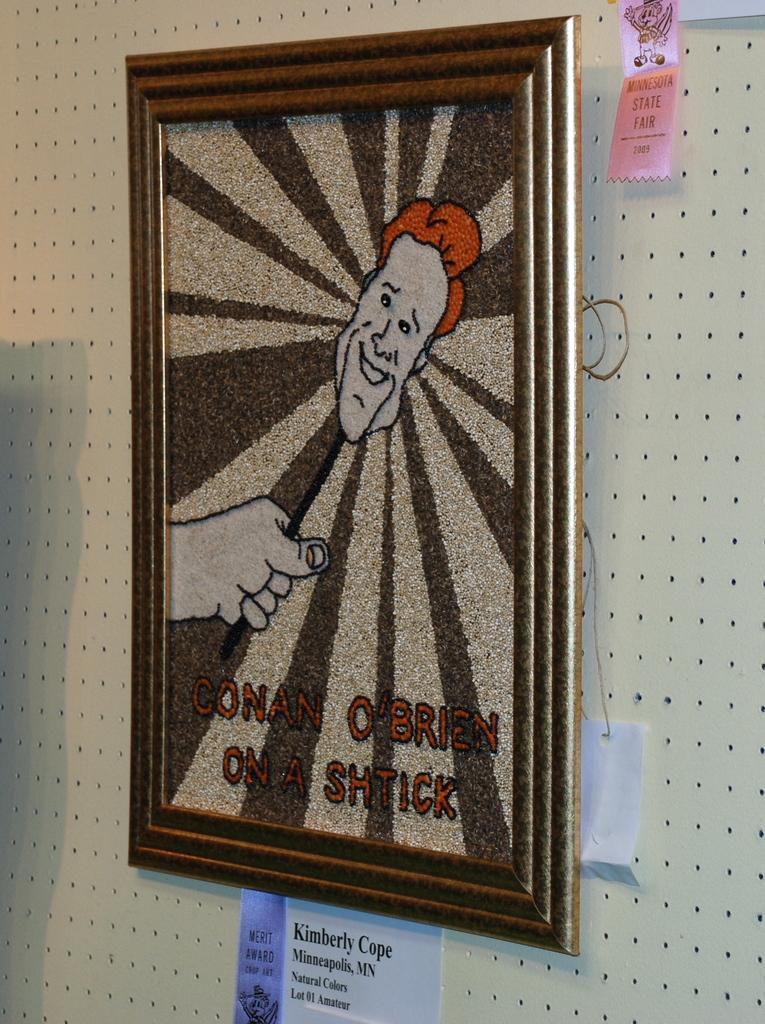<image>
Write a terse but informative summary of the picture. An image of Conan O'Brien on a Shtick on a carpet like material in a frame on a wall. 